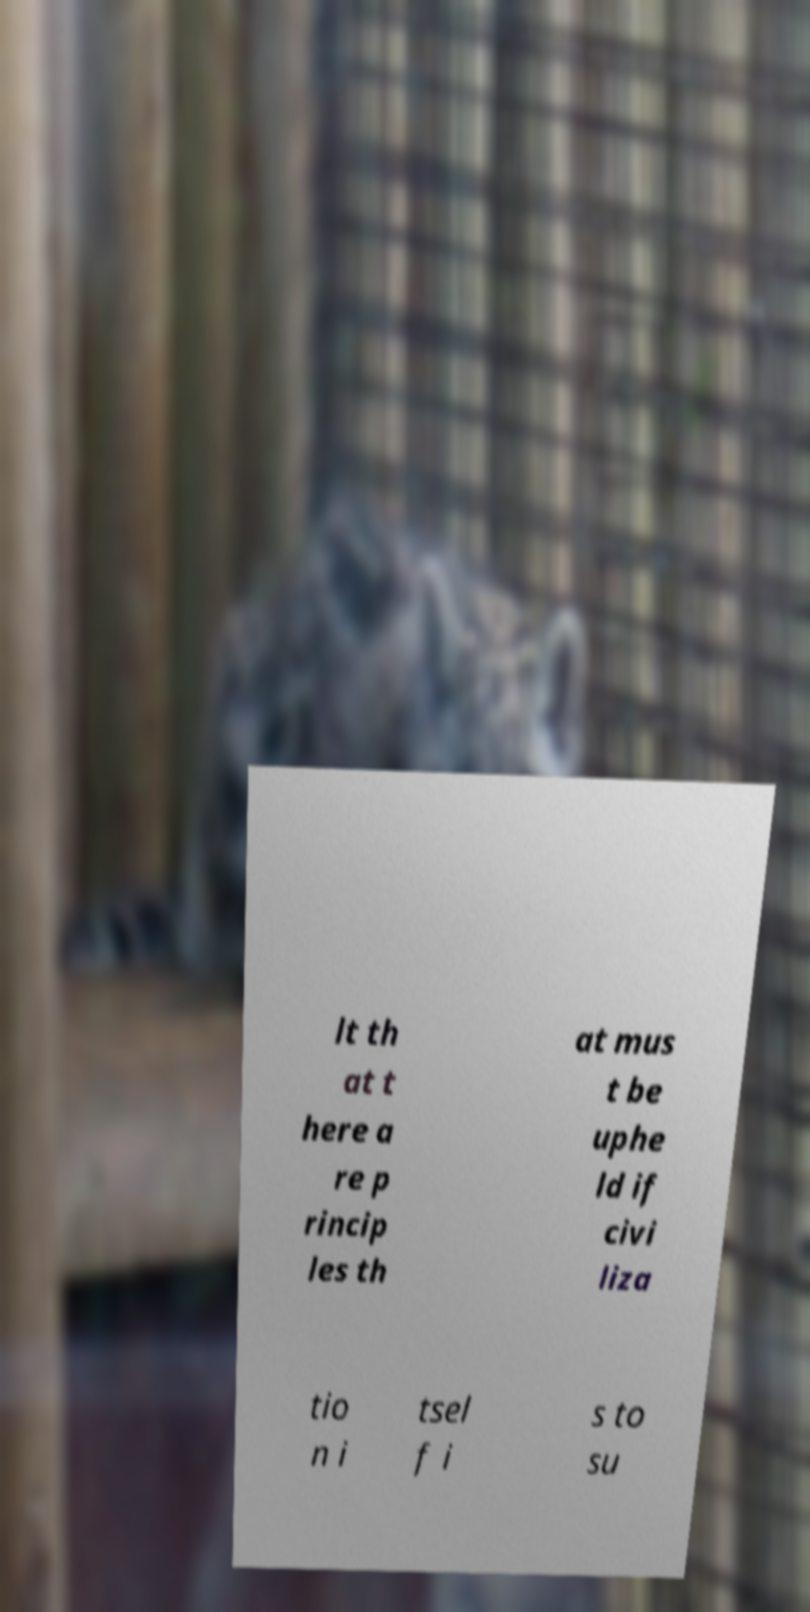Could you assist in decoding the text presented in this image and type it out clearly? lt th at t here a re p rincip les th at mus t be uphe ld if civi liza tio n i tsel f i s to su 